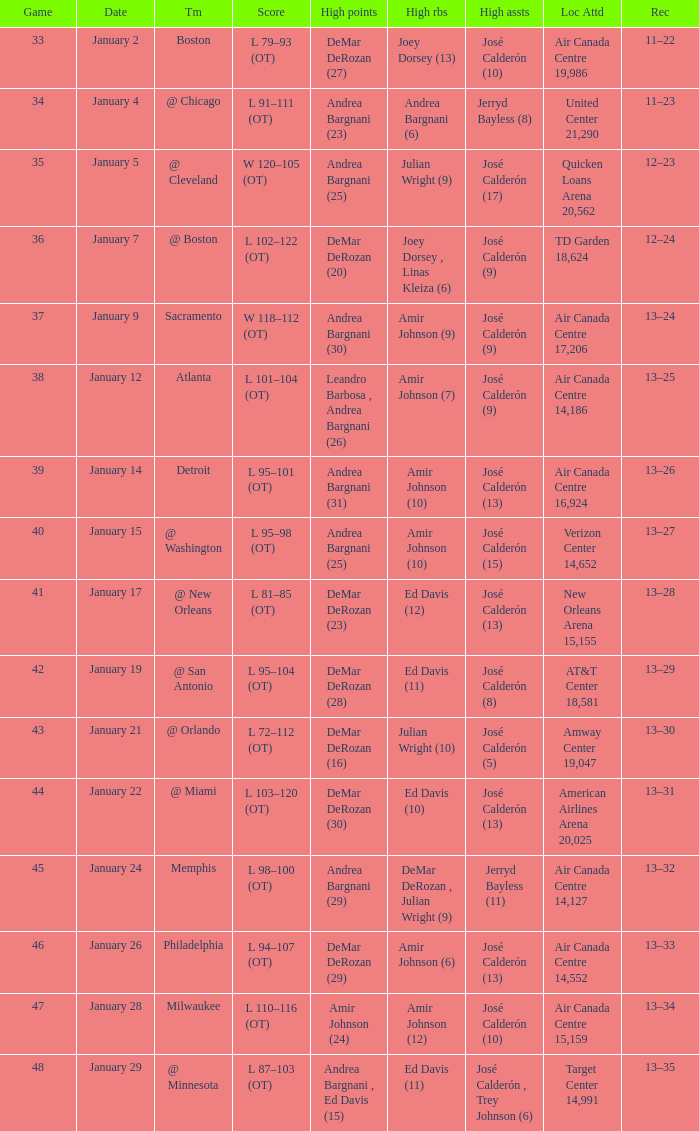Name the number of high rebounds for january 5 1.0. 